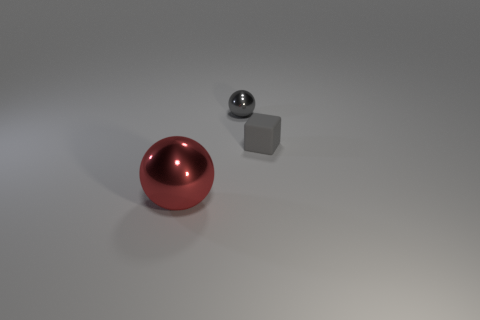What is the shape of the large red thing that is the same material as the gray ball?
Provide a short and direct response. Sphere. There is a metallic thing left of the gray metallic sphere; does it have the same shape as the tiny gray metallic thing?
Offer a very short reply. Yes. What number of things are gray metal objects or tiny gray rubber cylinders?
Your answer should be compact. 1. There is a object that is both in front of the tiny metal thing and right of the large metal object; what is its material?
Ensure brevity in your answer.  Rubber. Is the size of the gray sphere the same as the matte block?
Keep it short and to the point. Yes. There is a red thing that is in front of the thing that is to the right of the gray metallic thing; what size is it?
Your response must be concise. Large. What number of objects are both to the right of the gray metal thing and in front of the tiny rubber block?
Your response must be concise. 0. There is a object on the right side of the shiny object on the right side of the large red metal object; is there a large red shiny ball in front of it?
Ensure brevity in your answer.  Yes. There is a gray rubber thing that is the same size as the gray shiny thing; what is its shape?
Provide a succinct answer. Cube. Are there any metal spheres that have the same color as the tiny matte thing?
Your answer should be very brief. Yes. 